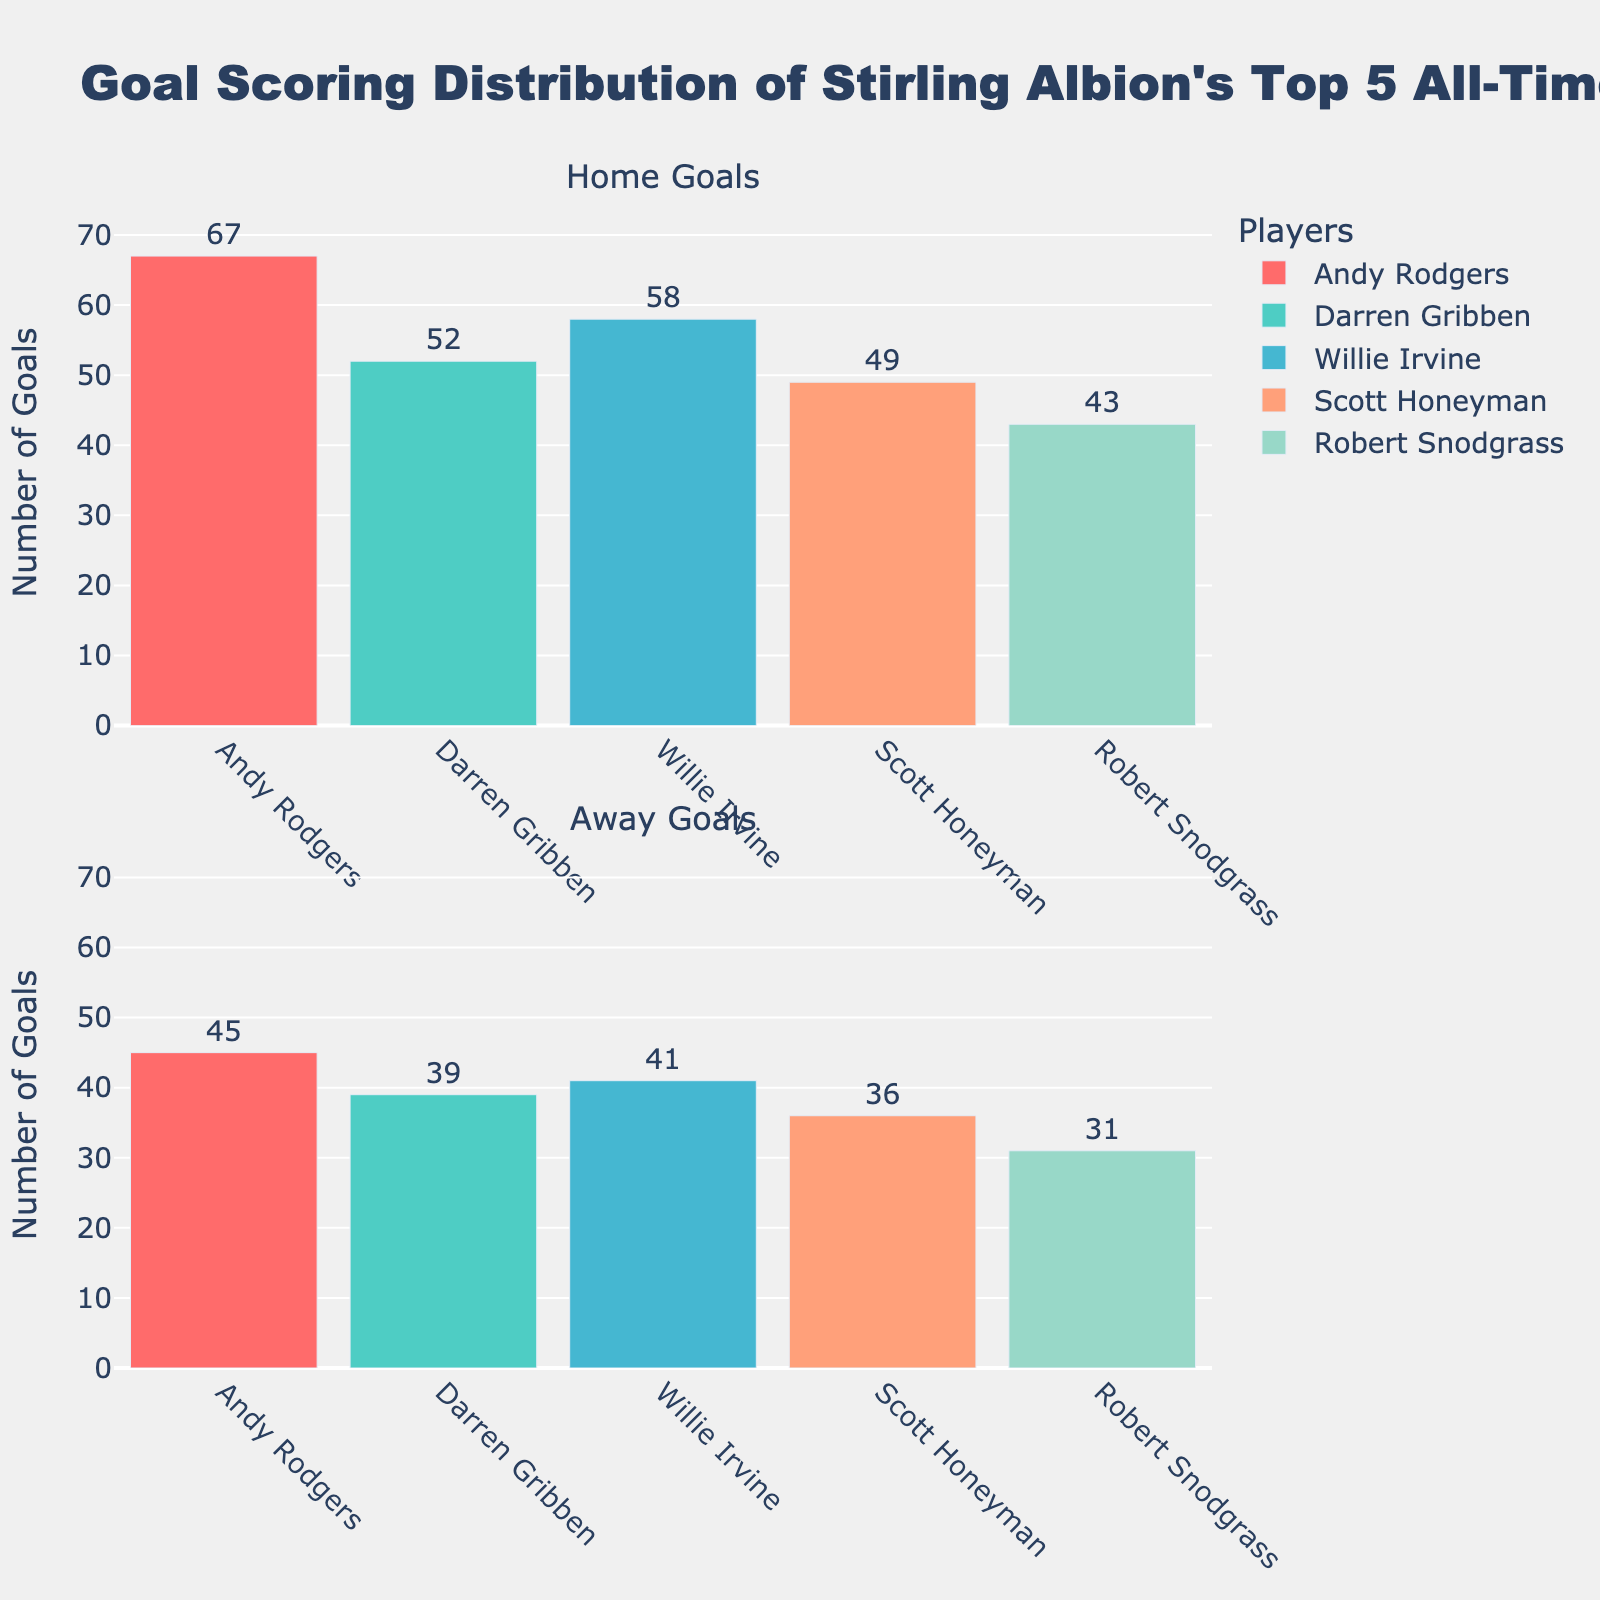What's the title of the figure? The title is prominently located at the top of the figure. It provides a summary of the visualization.
Answer: Goal Scoring Distribution of Stirling Albion's Top 5 All-Time Scorers How many total home goals did Andy Rodgers score? Refer to the first subplot under the "Home Goals" title. Find Andy Rodgers' bar and read the value displayed at the top.
Answer: 67 Which player scored the fewest home goals? Compare the heights and values of the bars in the "Home Goals" subplot. Identify the bar with the lowest value.
Answer: Robert Snodgrass What is the difference between Willie Irvine's home and away goals? Find Willie Irvine's home goals in the first subplot and his away goals in the second subplot. Subtract away goals from home goals.
Answer: 58 - 41 = 17 Who has a higher number of away goals, Scott Honeyman or Darren Gribben? Compare the bars representing Scott Honeyman and Darren Gribben in the "Away Goals" subplot.
Answer: Darren Gribben What is the combined home and away goals scored by Darren Gribben? Add Darren Gribben's home goals from the first subplot to his away goals from the second subplot.
Answer: 52 + 39 = 91 Which player's goals are closest in number between home and away games? Calculate the absolute difference between home and away goals for each player, and find the minimum difference.
Answer: Scott Honeyman (difference of 13) How many more home goals than away goals did Andy Rodgers score? Subtract the number of away goals scored by Andy Rodgers from his home goals.
Answer: 67 - 45 = 22 Rank the players by their home goals in descending order. Examine the "Home Goals" subplot and list players from highest to lowest home goals.
Answer: Andy Rodgers, Willie Irvine, Darren Gribben, Scott Honeyman, Robert Snodgrass What is the average number of away goals scored by the top 5 scorers? Sum up the away goals for all 5 players and divide by 5. (45 + 39 + 41 + 36 + 31) / 5 = 192 / 5 = 38.4
Answer: 38.4 